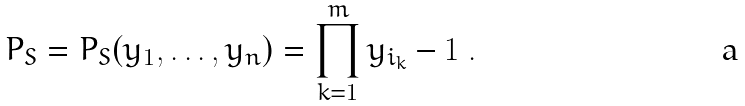Convert formula to latex. <formula><loc_0><loc_0><loc_500><loc_500>P _ { S } = P _ { S } ( y _ { 1 } , \dots , y _ { n } ) = \prod _ { k = 1 } ^ { m } y _ { i _ { k } } - 1 \ .</formula> 